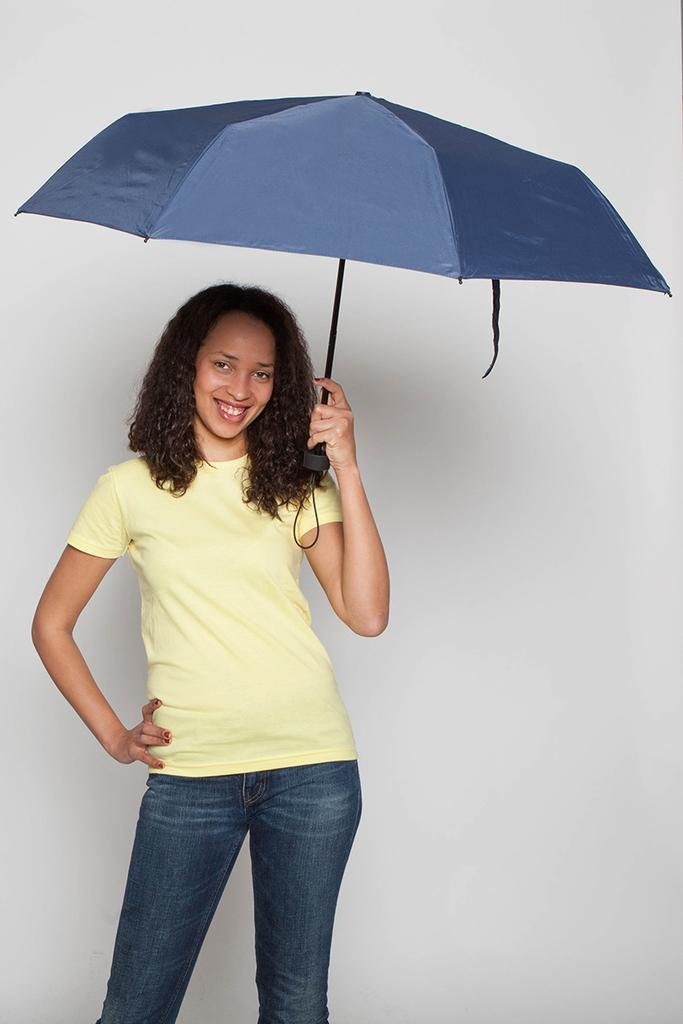Who is the main subject in the image? There is a woman in the image. Can you describe the woman's hair? The woman has curly hair. What is the woman doing in the image? The woman is standing. What object is the woman holding in her hand? The woman is holding an umbrella in one hand. What type of tree can be seen growing from the woman's toe in the image? There is no tree growing from the woman's toe in the image. 